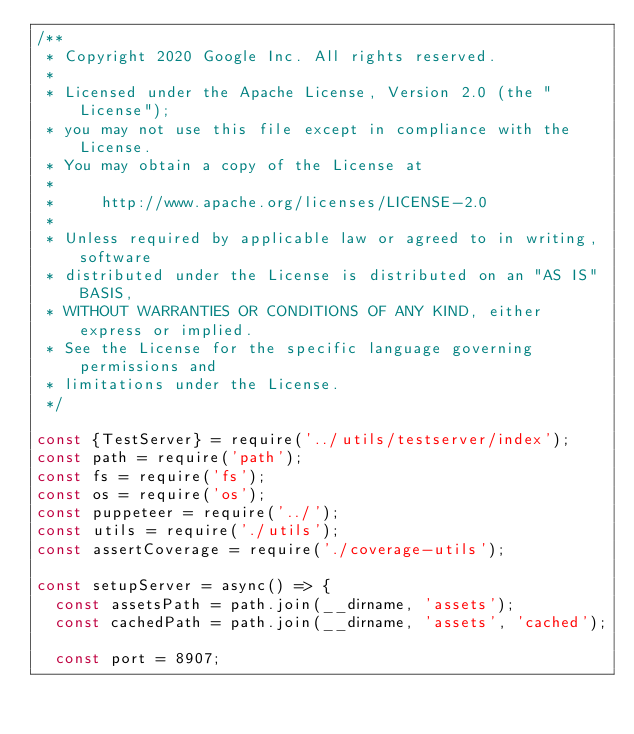<code> <loc_0><loc_0><loc_500><loc_500><_JavaScript_>/**
 * Copyright 2020 Google Inc. All rights reserved.
 *
 * Licensed under the Apache License, Version 2.0 (the "License");
 * you may not use this file except in compliance with the License.
 * You may obtain a copy of the License at
 *
 *     http://www.apache.org/licenses/LICENSE-2.0
 *
 * Unless required by applicable law or agreed to in writing, software
 * distributed under the License is distributed on an "AS IS" BASIS,
 * WITHOUT WARRANTIES OR CONDITIONS OF ANY KIND, either express or implied.
 * See the License for the specific language governing permissions and
 * limitations under the License.
 */

const {TestServer} = require('../utils/testserver/index');
const path = require('path');
const fs = require('fs');
const os = require('os');
const puppeteer = require('../');
const utils = require('./utils');
const assertCoverage = require('./coverage-utils');

const setupServer = async() => {
  const assetsPath = path.join(__dirname, 'assets');
  const cachedPath = path.join(__dirname, 'assets', 'cached');

  const port = 8907;</code> 